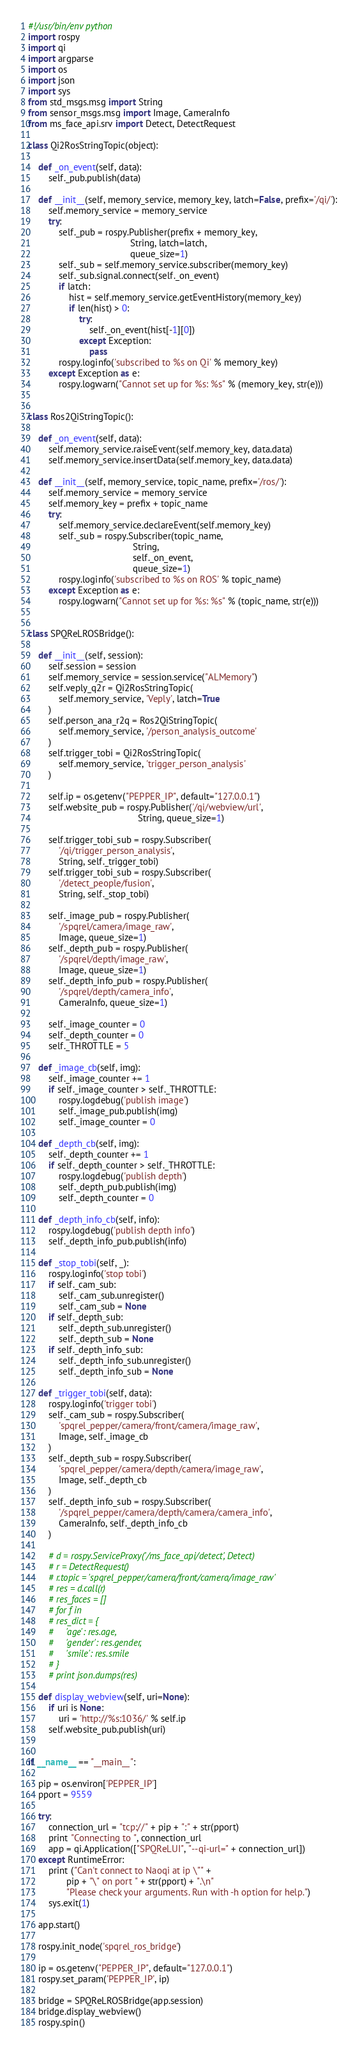Convert code to text. <code><loc_0><loc_0><loc_500><loc_500><_Python_>#!/usr/bin/env python
import rospy
import qi
import argparse
import os
import json
import sys
from std_msgs.msg import String
from sensor_msgs.msg import Image, CameraInfo
from ms_face_api.srv import Detect, DetectRequest

class Qi2RosStringTopic(object):

    def _on_event(self, data):
        self._pub.publish(data)

    def __init__(self, memory_service, memory_key, latch=False, prefix='/qi/'):
        self.memory_service = memory_service
        try:
            self._pub = rospy.Publisher(prefix + memory_key,
                                        String, latch=latch,
                                        queue_size=1)
            self._sub = self.memory_service.subscriber(memory_key)
            self._sub.signal.connect(self._on_event)
            if latch:
                hist = self.memory_service.getEventHistory(memory_key)
                if len(hist) > 0:
                    try:
                        self._on_event(hist[-1][0])
                    except Exception:
                        pass
            rospy.loginfo('subscribed to %s on Qi' % memory_key)
        except Exception as e:
            rospy.logwarn("Cannot set up for %s: %s" % (memory_key, str(e)))


class Ros2QiStringTopic():

    def _on_event(self, data):
        self.memory_service.raiseEvent(self.memory_key, data.data)
        self.memory_service.insertData(self.memory_key, data.data)

    def __init__(self, memory_service, topic_name, prefix='/ros/'):
        self.memory_service = memory_service
        self.memory_key = prefix + topic_name
        try:
            self.memory_service.declareEvent(self.memory_key)
            self._sub = rospy.Subscriber(topic_name,
                                         String,
                                         self._on_event,
                                         queue_size=1)
            rospy.loginfo('subscribed to %s on ROS' % topic_name)
        except Exception as e:
            rospy.logwarn("Cannot set up for %s: %s" % (topic_name, str(e)))


class SPQReLROSBridge():

    def __init__(self, session):
        self.session = session
        self.memory_service = session.service("ALMemory")
        self.veply_q2r = Qi2RosStringTopic(
            self.memory_service, 'Veply', latch=True
        )
        self.person_ana_r2q = Ros2QiStringTopic(
            self.memory_service, '/person_analysis_outcome'
        )
        self.trigger_tobi = Qi2RosStringTopic(
            self.memory_service, 'trigger_person_analysis'
        )

        self.ip = os.getenv("PEPPER_IP", default="127.0.0.1")
        self.website_pub = rospy.Publisher('/qi/webview/url',
                                           String, queue_size=1)

        self.trigger_tobi_sub = rospy.Subscriber(
            '/qi/trigger_person_analysis',
            String, self._trigger_tobi)
        self.trigger_tobi_sub = rospy.Subscriber(
            '/detect_people/fusion',
            String, self._stop_tobi)

        self._image_pub = rospy.Publisher(
            '/spqrel/camera/image_raw',
            Image, queue_size=1)
        self._depth_pub = rospy.Publisher(
            '/spqrel/depth/image_raw',
            Image, queue_size=1)
        self._depth_info_pub = rospy.Publisher(
            '/spqrel/depth/camera_info',
            CameraInfo, queue_size=1)

        self._image_counter = 0
        self._depth_counter = 0
        self._THROTTLE = 5

    def _image_cb(self, img):
        self._image_counter += 1
        if self._image_counter > self._THROTTLE:
            rospy.logdebug('publish image')
            self._image_pub.publish(img)
            self._image_counter = 0

    def _depth_cb(self, img):
        self._depth_counter += 1
        if self._depth_counter > self._THROTTLE:
            rospy.logdebug('publish depth')
            self._depth_pub.publish(img)
            self._depth_counter = 0

    def _depth_info_cb(self, info):
        rospy.logdebug('publish depth info')
        self._depth_info_pub.publish(info)

    def _stop_tobi(self, _):
        rospy.loginfo('stop tobi')
        if self._cam_sub:
            self._cam_sub.unregister()
            self._cam_sub = None
        if self._depth_sub:
            self._depth_sub.unregister()
            self._depth_sub = None
        if self._depth_info_sub:
            self._depth_info_sub.unregister()
            self._depth_info_sub = None

    def _trigger_tobi(self, data):
        rospy.loginfo('trigger tobi')
        self._cam_sub = rospy.Subscriber(
            'spqrel_pepper/camera/front/camera/image_raw',
            Image, self._image_cb
        )
        self._depth_sub = rospy.Subscriber(
            'spqrel_pepper/camera/depth/camera/image_raw',
            Image, self._depth_cb
        )
        self._depth_info_sub = rospy.Subscriber(
            '/spqrel_pepper/camera/depth/camera/camera_info',
            CameraInfo, self._depth_info_cb
        )

        # d = rospy.ServiceProxy('/ms_face_api/detect', Detect)
        # r = DetectRequest()
        # r.topic = 'spqrel_pepper/camera/front/camera/image_raw'
        # res = d.call(r)
        # res_faces = []
        # for f in
        # res_dict = {
        #     'age': res.age,
        #     'gender': res.gender,
        #     'smile': res.smile
        # }
        # print json.dumps(res)

    def display_webview(self, uri=None):
        if uri is None:
            uri = 'http://%s:1036/' % self.ip
        self.website_pub.publish(uri)


if __name__ == "__main__":

    pip = os.environ['PEPPER_IP']
    pport = 9559

    try:
        connection_url = "tcp://" + pip + ":" + str(pport)
        print "Connecting to ", connection_url
        app = qi.Application(["SPQReLUI", "--qi-url=" + connection_url])
    except RuntimeError:
        print ("Can't connect to Naoqi at ip \"" +
               pip + "\" on port " + str(pport) + ".\n"
               "Please check your arguments. Run with -h option for help.")
        sys.exit(1)

    app.start()

    rospy.init_node('spqrel_ros_bridge')

    ip = os.getenv("PEPPER_IP", default="127.0.0.1")
    rospy.set_param('PEPPER_IP', ip)

    bridge = SPQReLROSBridge(app.session)
    bridge.display_webview()
    rospy.spin()
</code> 